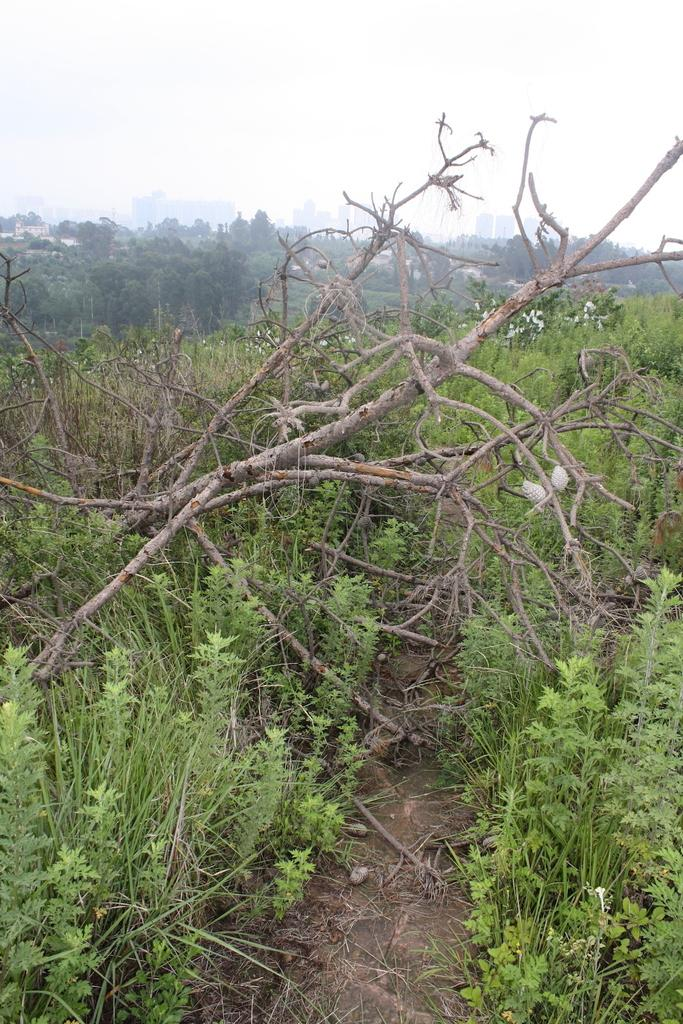What type of vegetation is in the foreground of the image? There are trees and grass in the foreground of the image. What structures can be seen in the background of the image? There are buildings in the background of the image. What other natural elements are visible in the background of the image? There are trees in the background of the image. What is visible at the top of the image? The sky is visible at the top of the image. What type of lead can be seen in the image? There is no lead present in the image. 